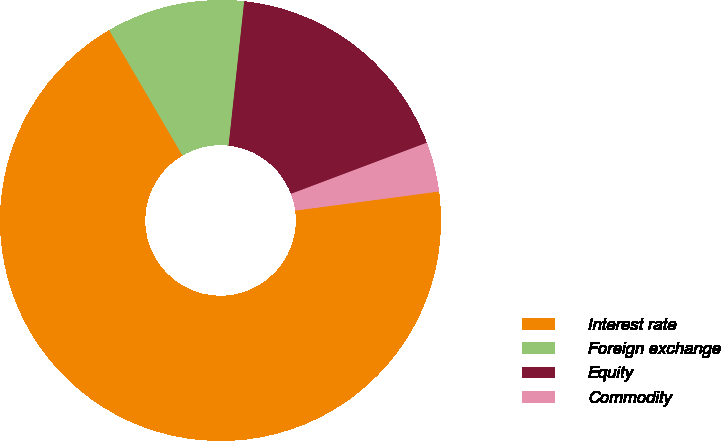Convert chart to OTSL. <chart><loc_0><loc_0><loc_500><loc_500><pie_chart><fcel>Interest rate<fcel>Foreign exchange<fcel>Equity<fcel>Commodity<nl><fcel>68.68%<fcel>10.14%<fcel>17.55%<fcel>3.63%<nl></chart> 